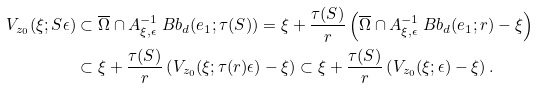Convert formula to latex. <formula><loc_0><loc_0><loc_500><loc_500>V _ { z _ { 0 } } ( \xi ; S \epsilon ) & \subset \overline { \Omega } \cap A ^ { - 1 } _ { \xi , \epsilon } \ B b _ { d } ( e _ { 1 } ; \tau ( S ) ) = \xi + \frac { \tau ( S ) } { r } \left ( \overline { \Omega } \cap A ^ { - 1 } _ { \xi , \epsilon } \ B b _ { d } ( e _ { 1 } ; r ) - \xi \right ) \\ & \subset \xi + \frac { \tau ( S ) } { r } \left ( V _ { z _ { 0 } } ( \xi ; \tau ( r ) \epsilon ) - \xi \right ) \subset \xi + \frac { \tau ( S ) } { r } \left ( V _ { z _ { 0 } } ( \xi ; \epsilon ) - \xi \right ) .</formula> 